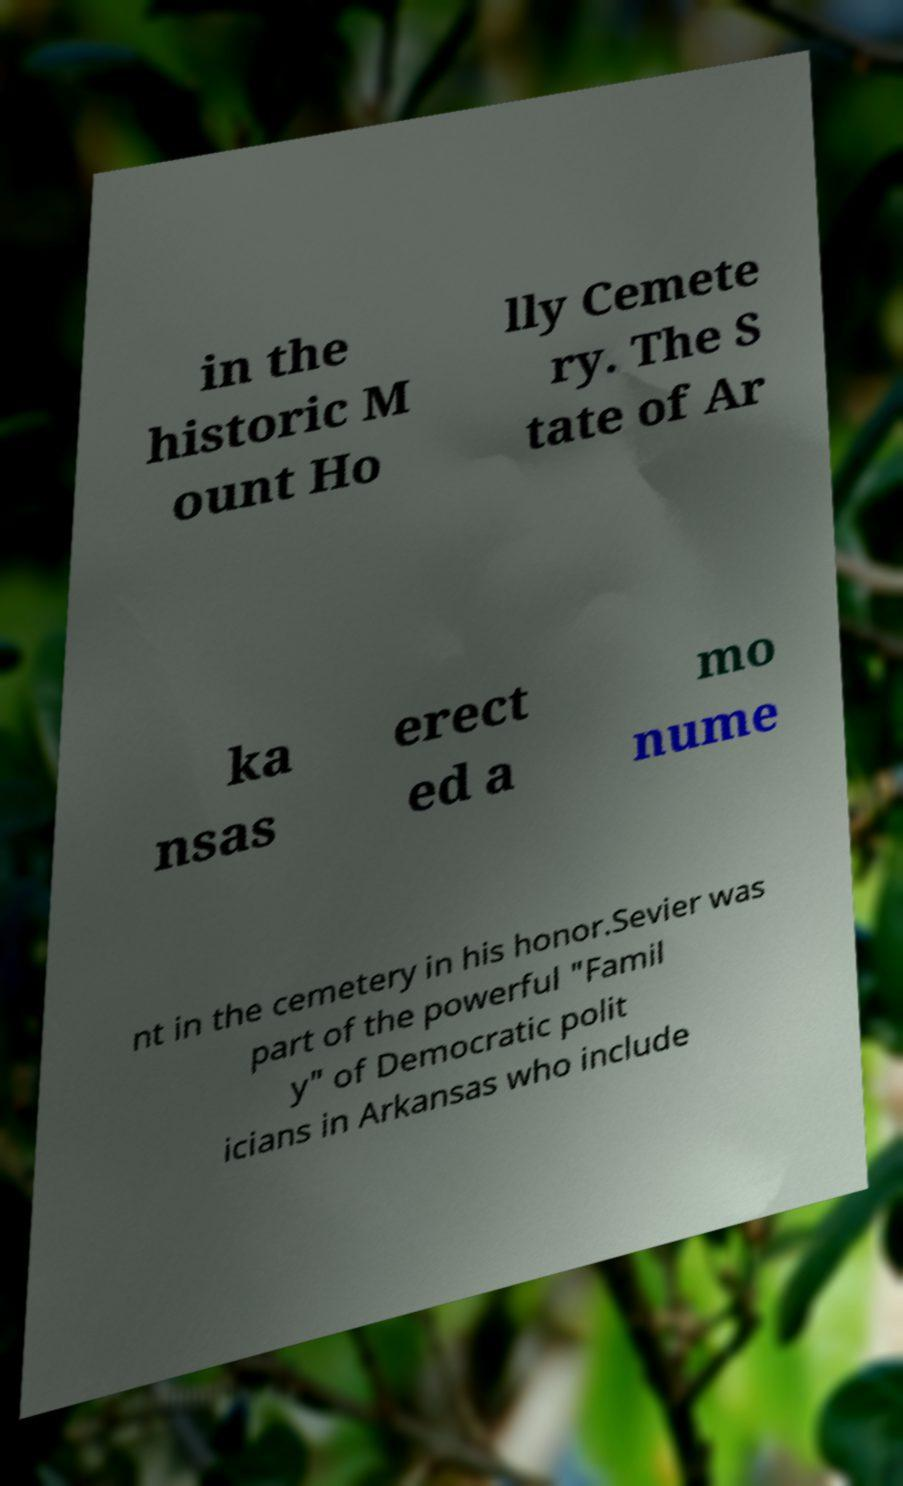Please read and relay the text visible in this image. What does it say? in the historic M ount Ho lly Cemete ry. The S tate of Ar ka nsas erect ed a mo nume nt in the cemetery in his honor.Sevier was part of the powerful "Famil y" of Democratic polit icians in Arkansas who include 